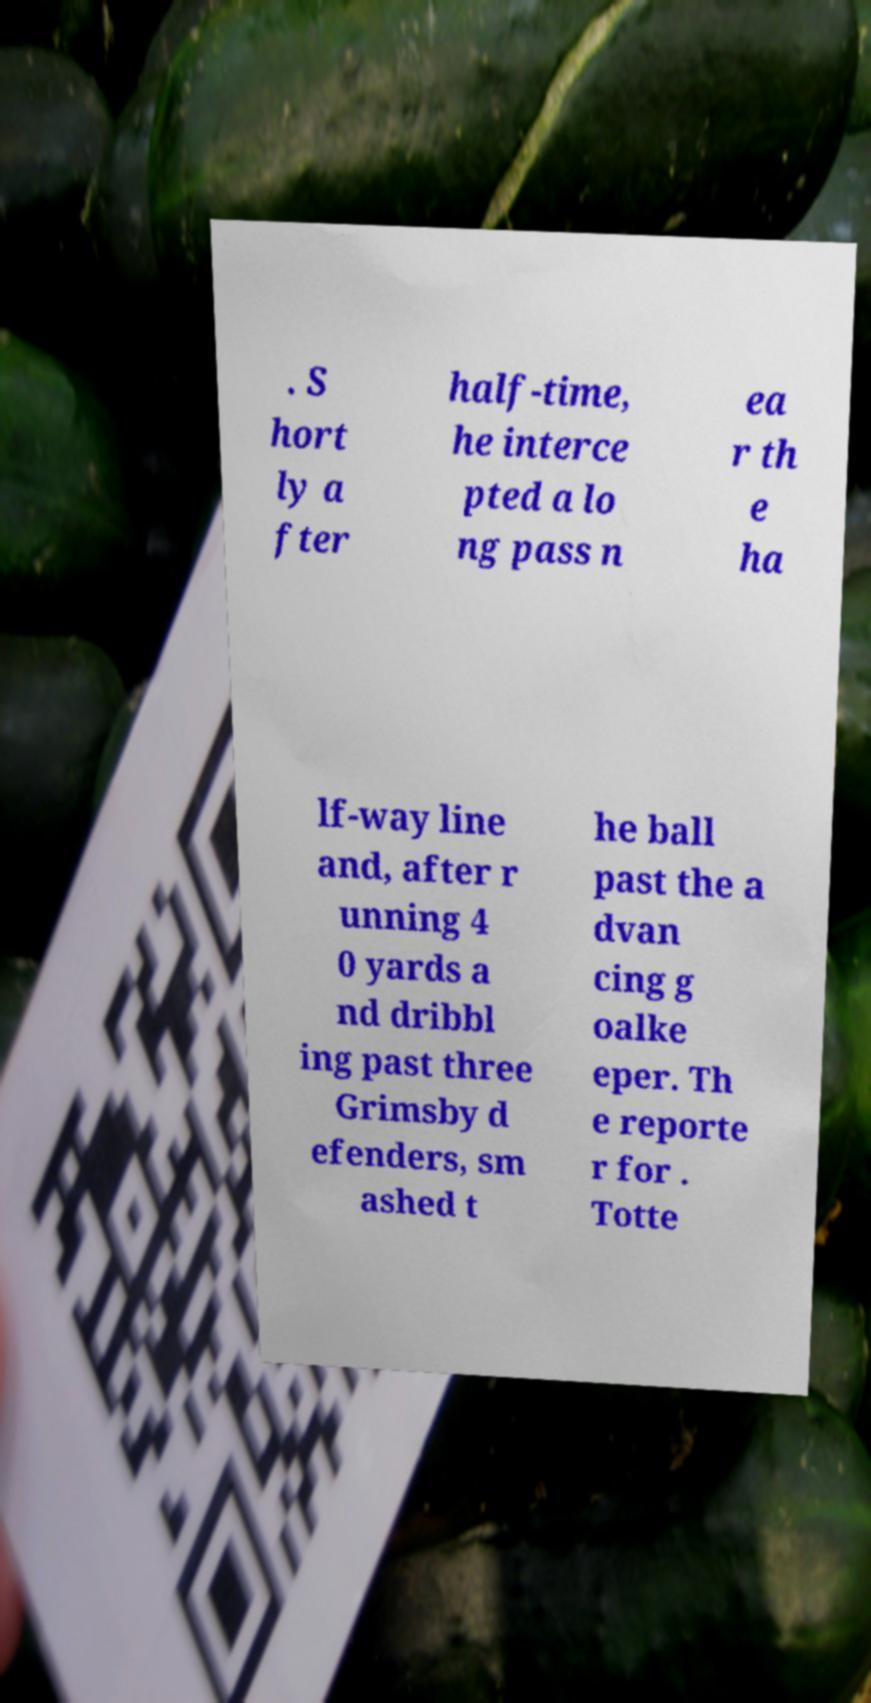Please identify and transcribe the text found in this image. . S hort ly a fter half-time, he interce pted a lo ng pass n ea r th e ha lf-way line and, after r unning 4 0 yards a nd dribbl ing past three Grimsby d efenders, sm ashed t he ball past the a dvan cing g oalke eper. Th e reporte r for . Totte 